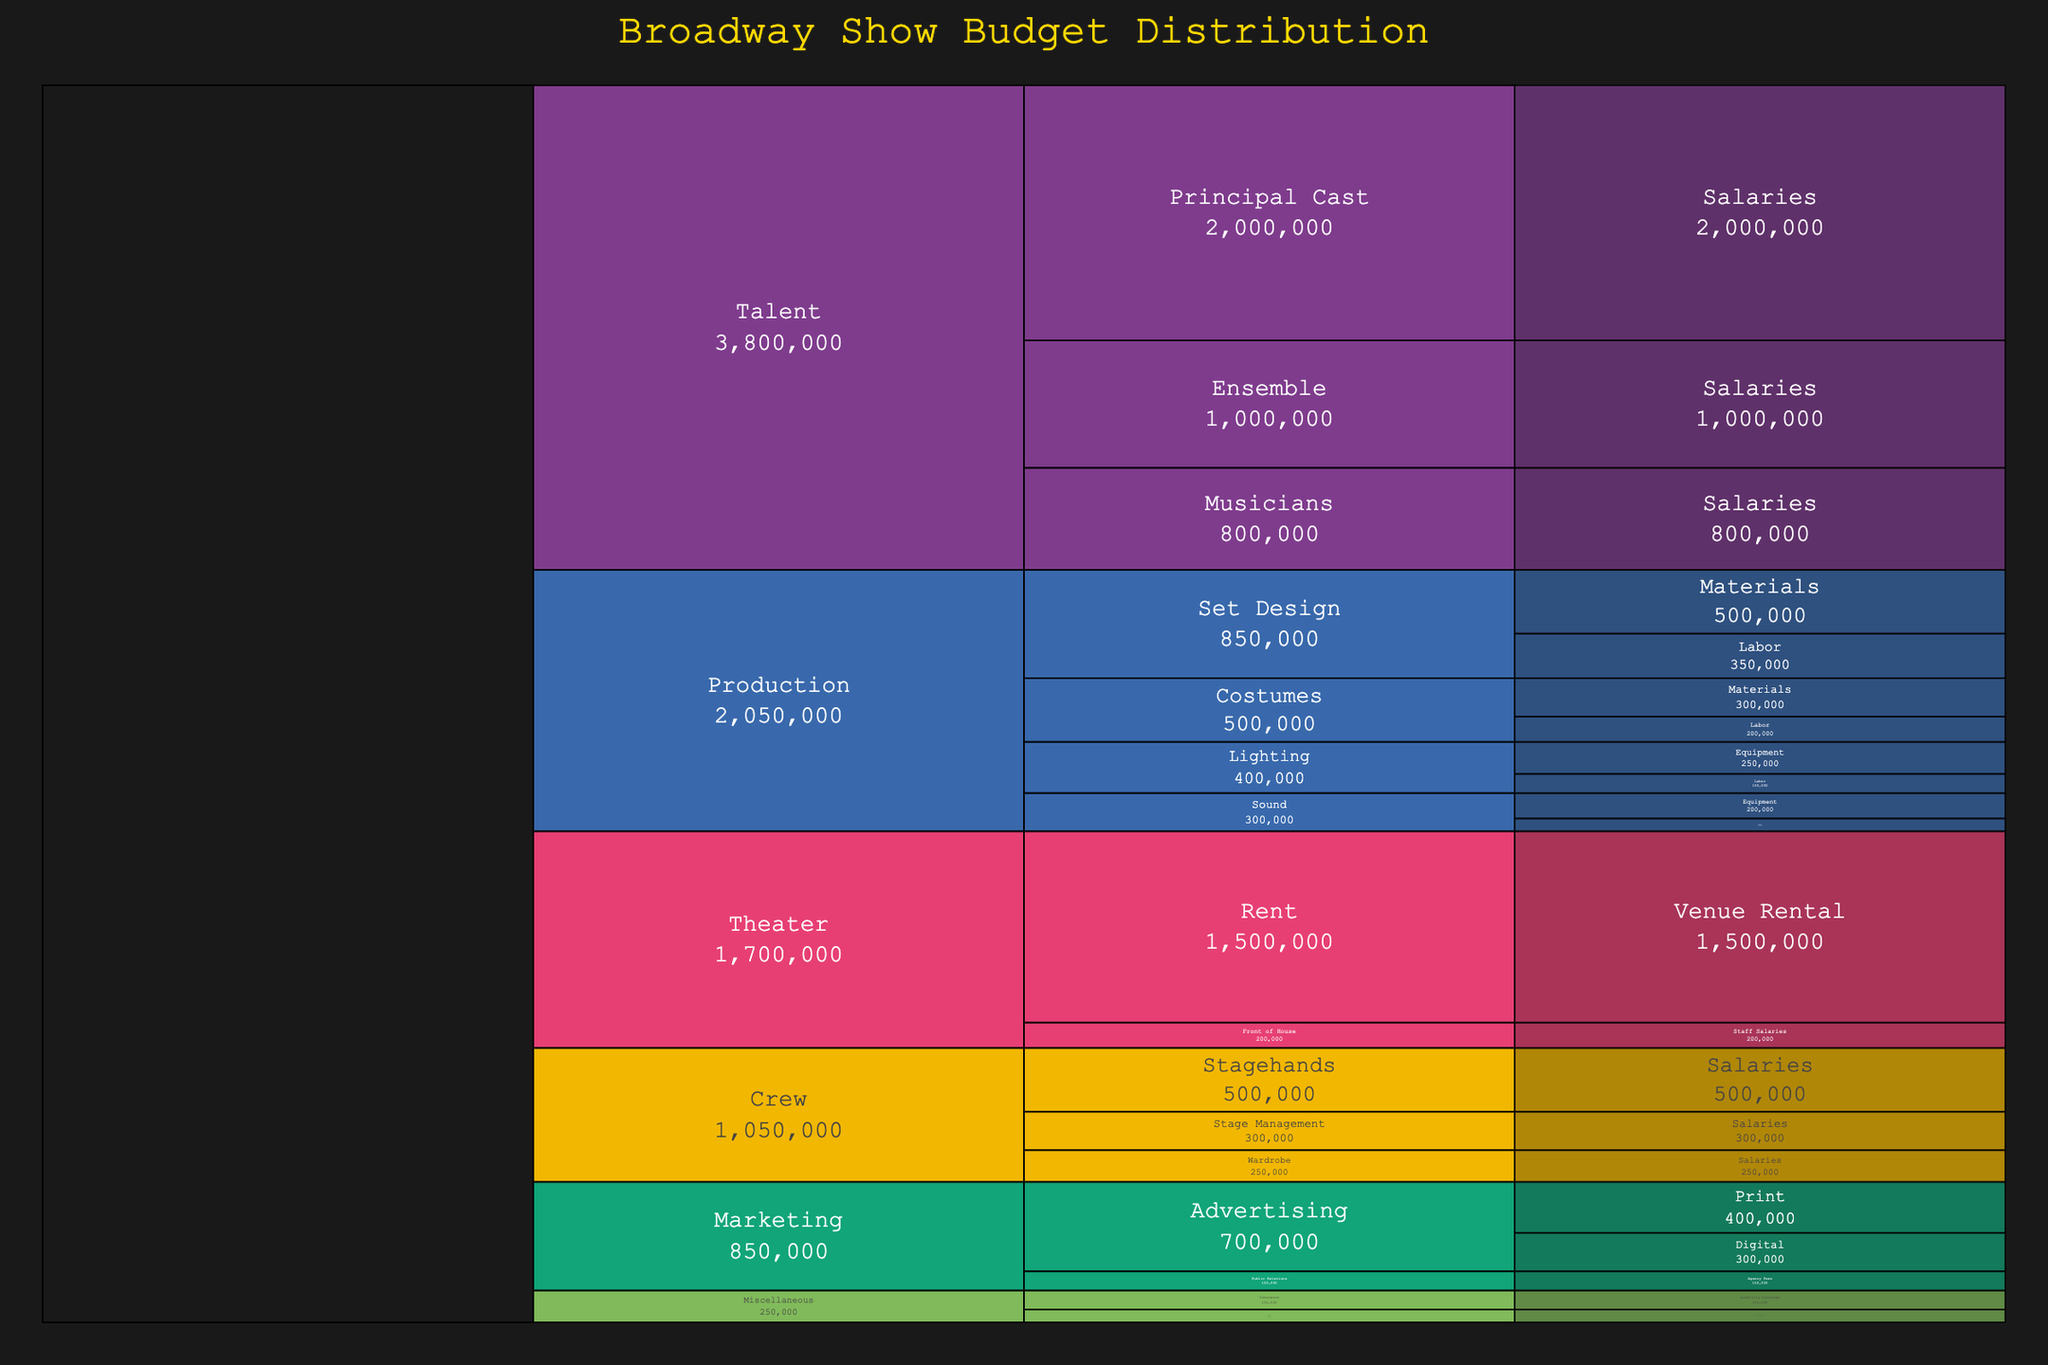What's the total budget for the Broadway show? To find the total budget, sum up the cost of all items across all categories. The values are identified by the 'Cost' column in the data provided. The sum is: 500000 + 350000 + 300000 + 200000 + 250000 + 150000 + 200000 + 100000 + 2000000 + 1000000 + 800000 + 300000 + 500000 + 250000 + 400000 + 300000 + 150000 + 1500000 + 200000 + 150000 + 100000 = 9,450,000
Answer: $9,450,000 Which category has the highest budget allocation? By observing the Icicle Chart, it should be clear which block occupies the largest area. In this case, the 'Talent' category has the largest allocation, encompassing salaries for the principal cast, ensemble, and musicians. This can be visually identified due to its size being larger than other categories.
Answer: Talent What's the combined cost of Lighting and Sound set equipment? Locate both the Lighting and Sound categories, then find the subcategories 'Equipment' under each. Sum their respective costs: 250000 (Lighting) + 200000 (Sound) = 450000
Answer: $450,000 How does the budget for 'Set Design: Labor' compare to 'Costumes: Labor'? Locate the respective segments for 'Set Design: Labor' and 'Costumes: Labor' within the Production category. 'Set Design: Labor' has a cost of 350,000, while 'Costumes: Labor' has a cost of 200,000. The difference can then be calculated.
Answer: Set Design: Labor is higher by $150,000 What percentage of the total budget is spent on 'Venue Rental'? The total budget is 9,450,000. The cost of venue rental is 1,500,000. Calculate the percentage by (1,500,000 / 9,450,000) * 100 = 15.87%
Answer: 15.87% What is the least expensive item in the Miscellaneous category? The Miscellaneous category contains 'Insurance: Liability Coverage' and 'Legal: Contracts and Licensing'. Compare their costs: 150,000 (Insurance) and 100,000 (Legal). The item with the lowest cost is 'Legal: Contracts and Licensing'.
Answer: Legal: Contracts and Licensing 